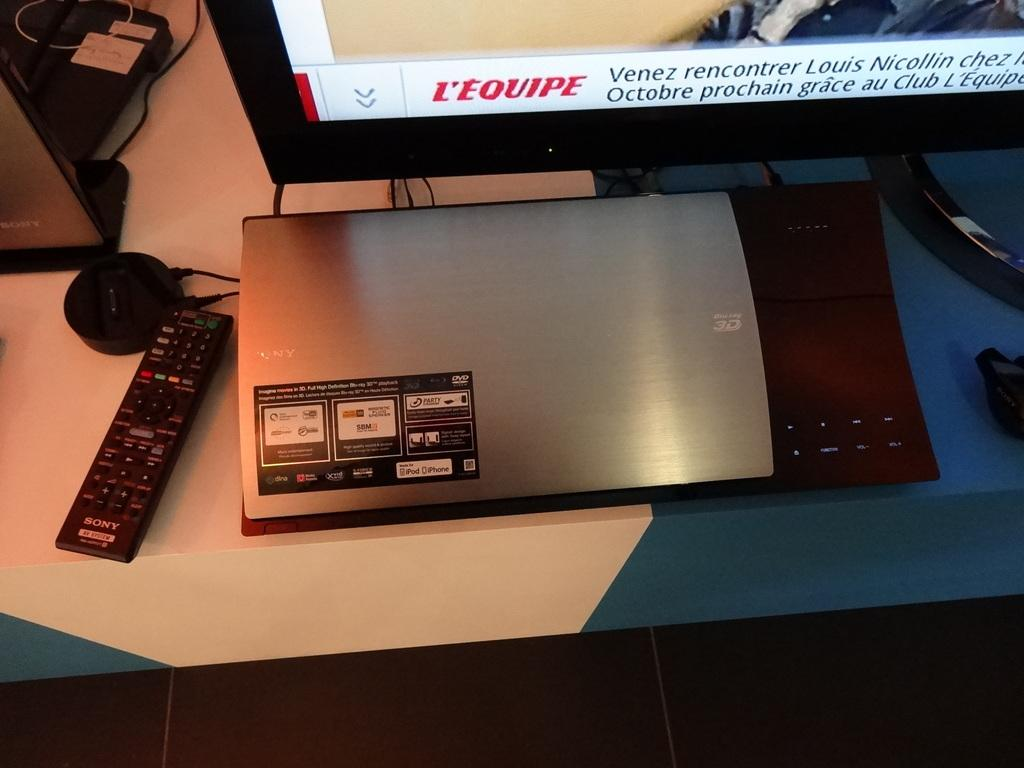<image>
Offer a succinct explanation of the picture presented. a television that says L'equipe on the lower left screen 